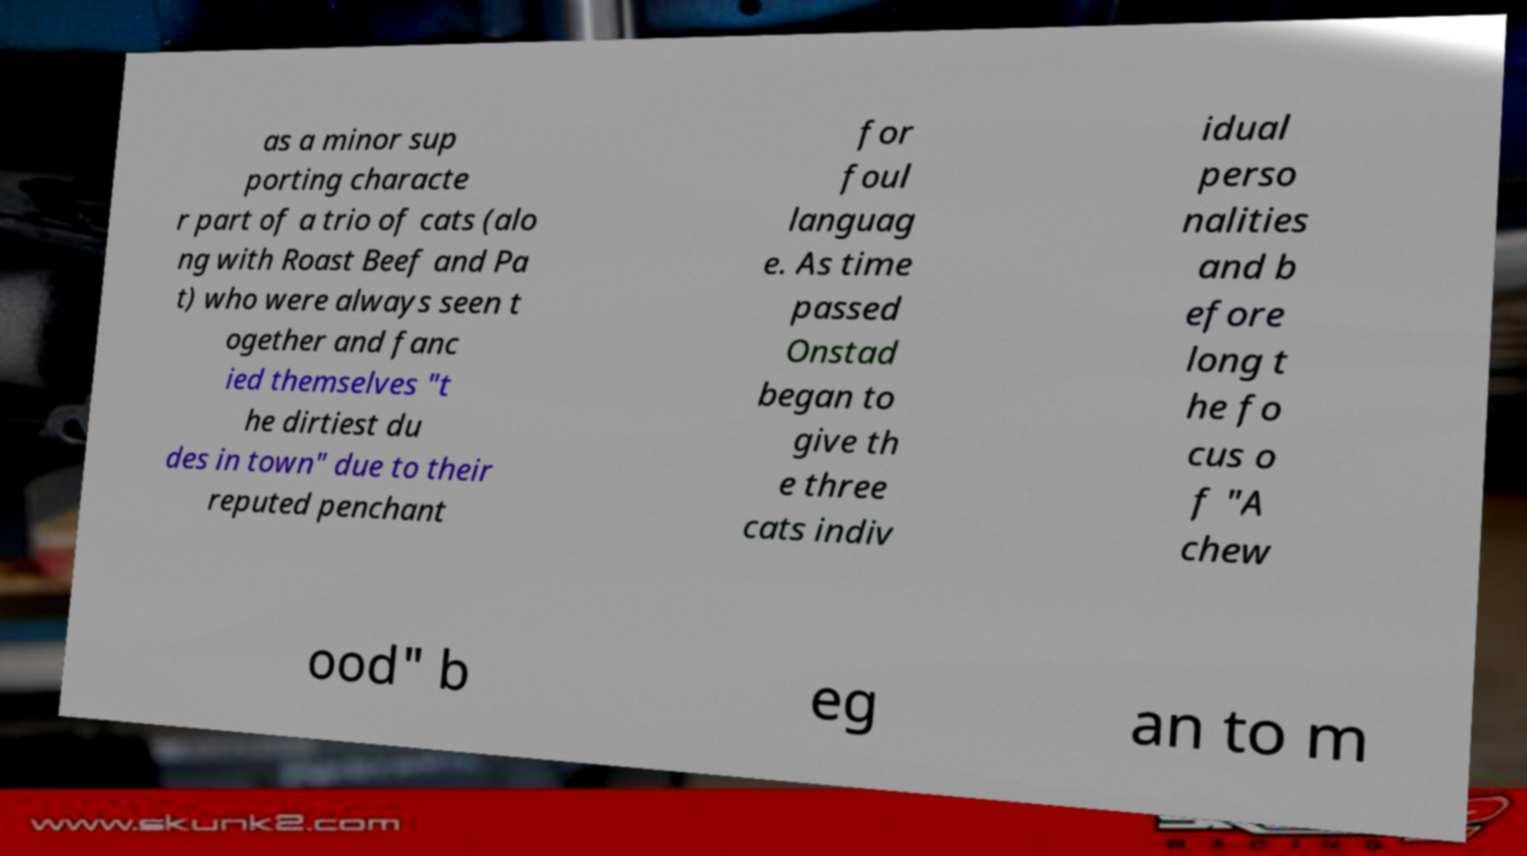I need the written content from this picture converted into text. Can you do that? as a minor sup porting characte r part of a trio of cats (alo ng with Roast Beef and Pa t) who were always seen t ogether and fanc ied themselves "t he dirtiest du des in town" due to their reputed penchant for foul languag e. As time passed Onstad began to give th e three cats indiv idual perso nalities and b efore long t he fo cus o f "A chew ood" b eg an to m 